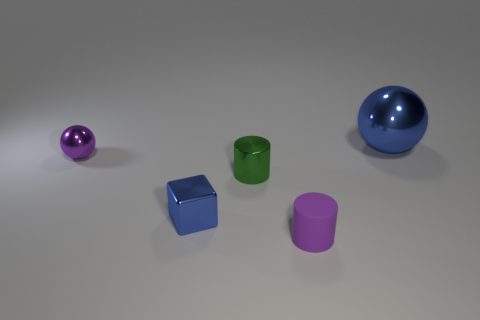Add 3 tiny cyan matte things. How many objects exist? 8 Subtract all spheres. How many objects are left? 3 Add 4 tiny matte things. How many tiny matte things exist? 5 Subtract 0 cyan balls. How many objects are left? 5 Subtract all tiny blue shiny cubes. Subtract all small balls. How many objects are left? 3 Add 5 purple objects. How many purple objects are left? 7 